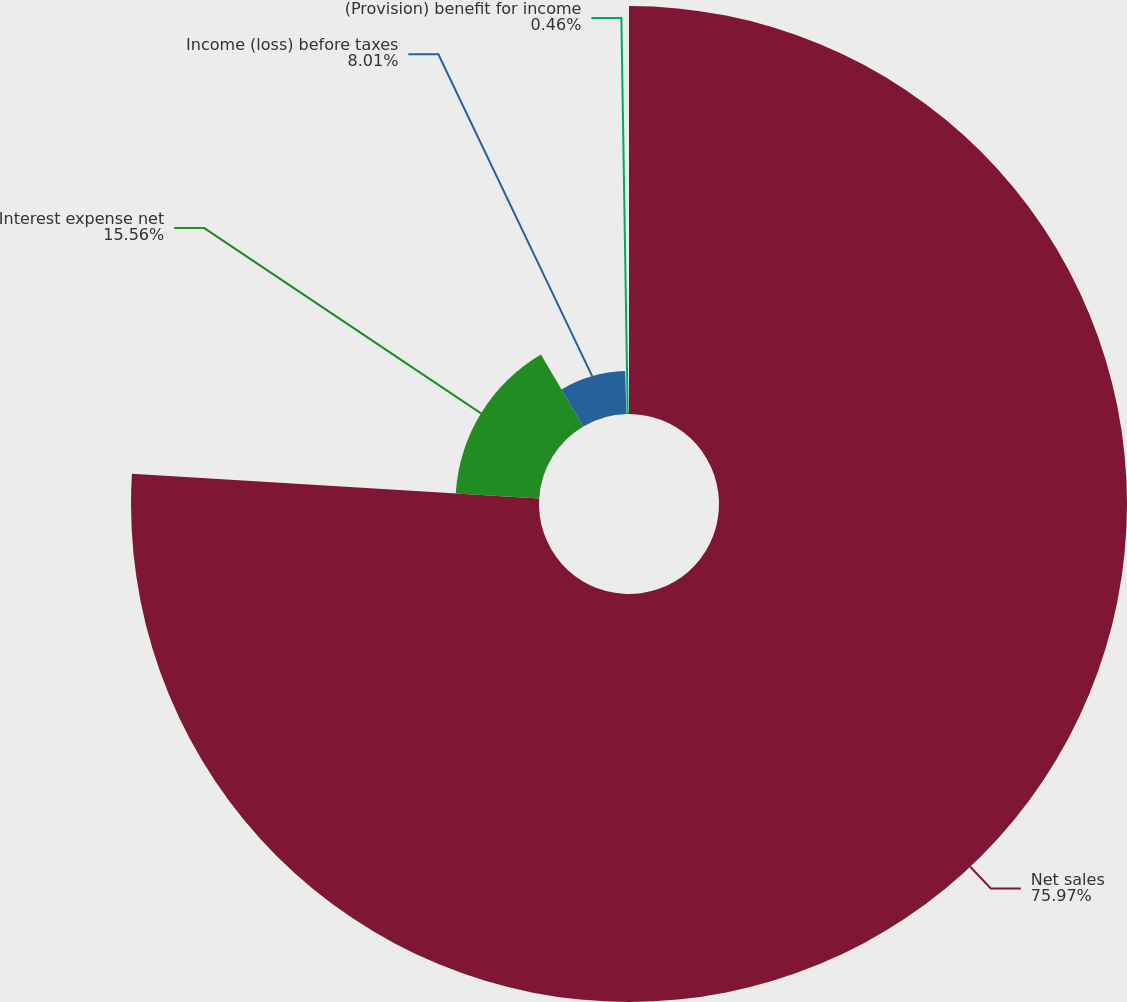Convert chart. <chart><loc_0><loc_0><loc_500><loc_500><pie_chart><fcel>Net sales<fcel>Interest expense net<fcel>Income (loss) before taxes<fcel>(Provision) benefit for income<nl><fcel>75.97%<fcel>15.56%<fcel>8.01%<fcel>0.46%<nl></chart> 